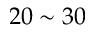Convert formula to latex. <formula><loc_0><loc_0><loc_500><loc_500>2 0 \sim 3 0</formula> 